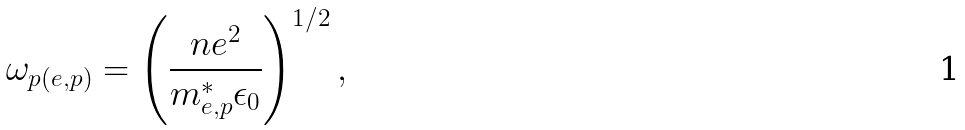<formula> <loc_0><loc_0><loc_500><loc_500>\omega _ { p ( e , p ) } = \left ( \frac { n e ^ { 2 } } { m _ { e , p } ^ { \ast } \epsilon _ { 0 } } \right ) ^ { 1 / 2 } ,</formula> 